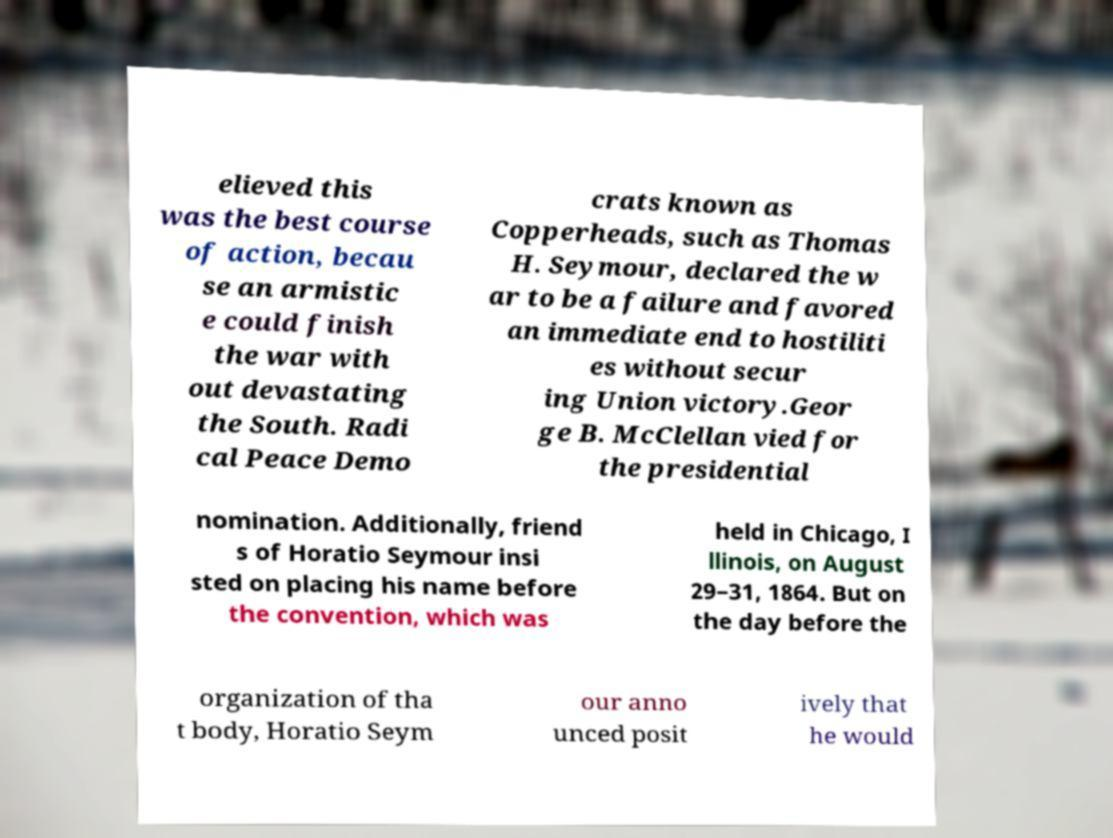Could you extract and type out the text from this image? elieved this was the best course of action, becau se an armistic e could finish the war with out devastating the South. Radi cal Peace Demo crats known as Copperheads, such as Thomas H. Seymour, declared the w ar to be a failure and favored an immediate end to hostiliti es without secur ing Union victory.Geor ge B. McClellan vied for the presidential nomination. Additionally, friend s of Horatio Seymour insi sted on placing his name before the convention, which was held in Chicago, I llinois, on August 29–31, 1864. But on the day before the organization of tha t body, Horatio Seym our anno unced posit ively that he would 